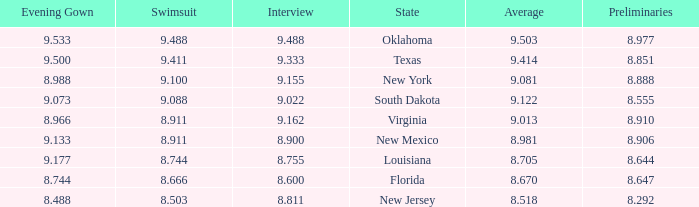 what's the preliminaries where state is south dakota 8.555. 